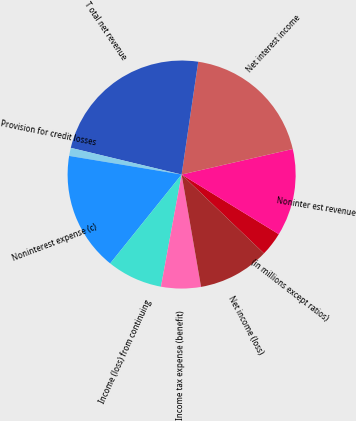Convert chart. <chart><loc_0><loc_0><loc_500><loc_500><pie_chart><fcel>(in millions except ratios)<fcel>Noninter est revenue<fcel>Net interest income<fcel>T otal net revenue<fcel>Provision for credit losses<fcel>Noninterest expense (c)<fcel>Income (loss) from continuing<fcel>Income tax expense (benefit)<fcel>Net income (loss)<nl><fcel>3.39%<fcel>12.36%<fcel>19.08%<fcel>23.56%<fcel>1.15%<fcel>16.84%<fcel>7.87%<fcel>5.63%<fcel>10.12%<nl></chart> 